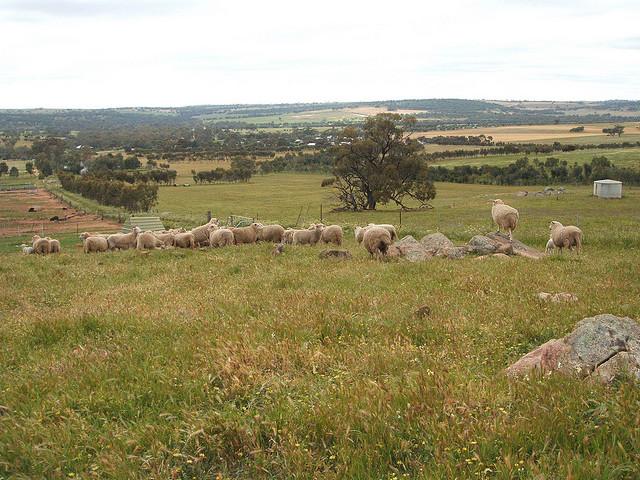What animals are these?
Give a very brief answer. Sheep. How many sheep?
Give a very brief answer. 30. Is this a heavily populated area?
Answer briefly. No. How many animals are in this photo?
Answer briefly. 20. Have the sheep been recently shorn?
Be succinct. No. 